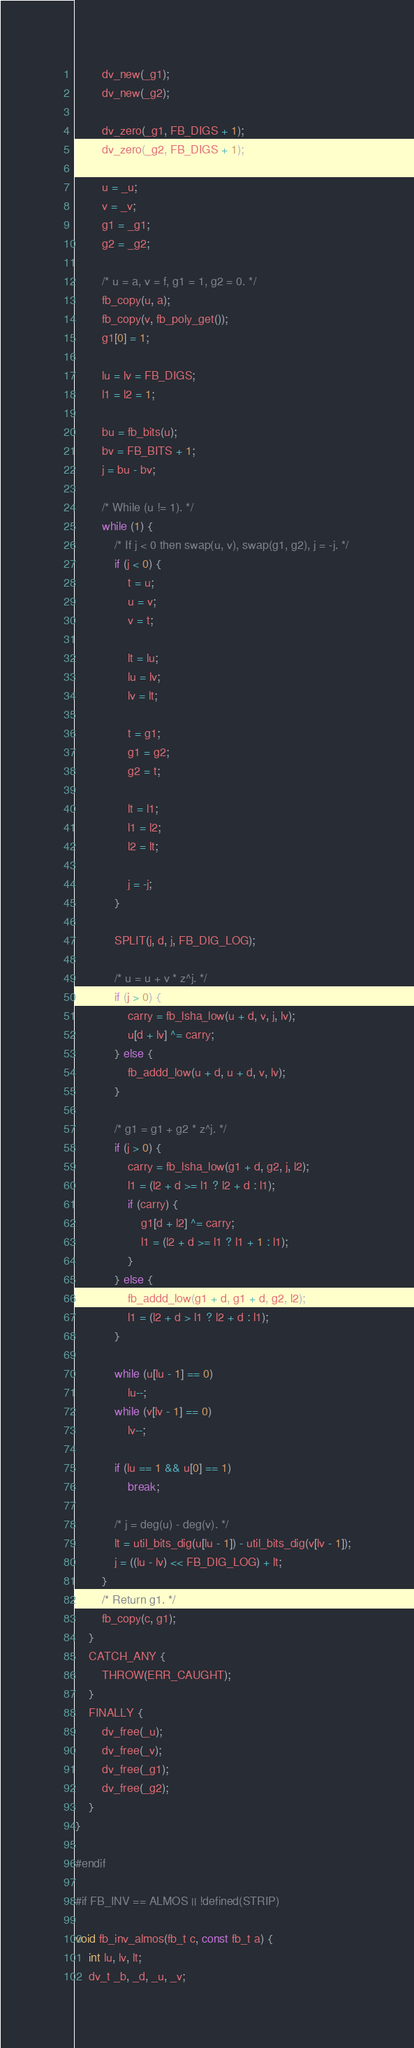Convert code to text. <code><loc_0><loc_0><loc_500><loc_500><_C_>		dv_new(_g1);
		dv_new(_g2);

		dv_zero(_g1, FB_DIGS + 1);
		dv_zero(_g2, FB_DIGS + 1);

		u = _u;
		v = _v;
		g1 = _g1;
		g2 = _g2;

		/* u = a, v = f, g1 = 1, g2 = 0. */
		fb_copy(u, a);
		fb_copy(v, fb_poly_get());
		g1[0] = 1;

		lu = lv = FB_DIGS;
		l1 = l2 = 1;

		bu = fb_bits(u);
		bv = FB_BITS + 1;
		j = bu - bv;

		/* While (u != 1). */
		while (1) {
			/* If j < 0 then swap(u, v), swap(g1, g2), j = -j. */
			if (j < 0) {
				t = u;
				u = v;
				v = t;

				lt = lu;
				lu = lv;
				lv = lt;

				t = g1;
				g1 = g2;
				g2 = t;

				lt = l1;
				l1 = l2;
				l2 = lt;

				j = -j;
			}

			SPLIT(j, d, j, FB_DIG_LOG);

			/* u = u + v * z^j. */
			if (j > 0) {
				carry = fb_lsha_low(u + d, v, j, lv);
				u[d + lv] ^= carry;
			} else {
				fb_addd_low(u + d, u + d, v, lv);
			}

			/* g1 = g1 + g2 * z^j. */
			if (j > 0) {
				carry = fb_lsha_low(g1 + d, g2, j, l2);
				l1 = (l2 + d >= l1 ? l2 + d : l1);
				if (carry) {
					g1[d + l2] ^= carry;
					l1 = (l2 + d >= l1 ? l1 + 1 : l1);
				}
			} else {
				fb_addd_low(g1 + d, g1 + d, g2, l2);
				l1 = (l2 + d > l1 ? l2 + d : l1);
			}

			while (u[lu - 1] == 0)
				lu--;
			while (v[lv - 1] == 0)
				lv--;

			if (lu == 1 && u[0] == 1)
				break;

			/* j = deg(u) - deg(v). */
			lt = util_bits_dig(u[lu - 1]) - util_bits_dig(v[lv - 1]);
			j = ((lu - lv) << FB_DIG_LOG) + lt;
		}
		/* Return g1. */
		fb_copy(c, g1);
	}
	CATCH_ANY {
		THROW(ERR_CAUGHT);
	}
	FINALLY {
		dv_free(_u);
		dv_free(_v);
		dv_free(_g1);
		dv_free(_g2);
	}
}

#endif

#if FB_INV == ALMOS || !defined(STRIP)

void fb_inv_almos(fb_t c, const fb_t a) {
	int lu, lv, lt;
	dv_t _b, _d, _u, _v;</code> 